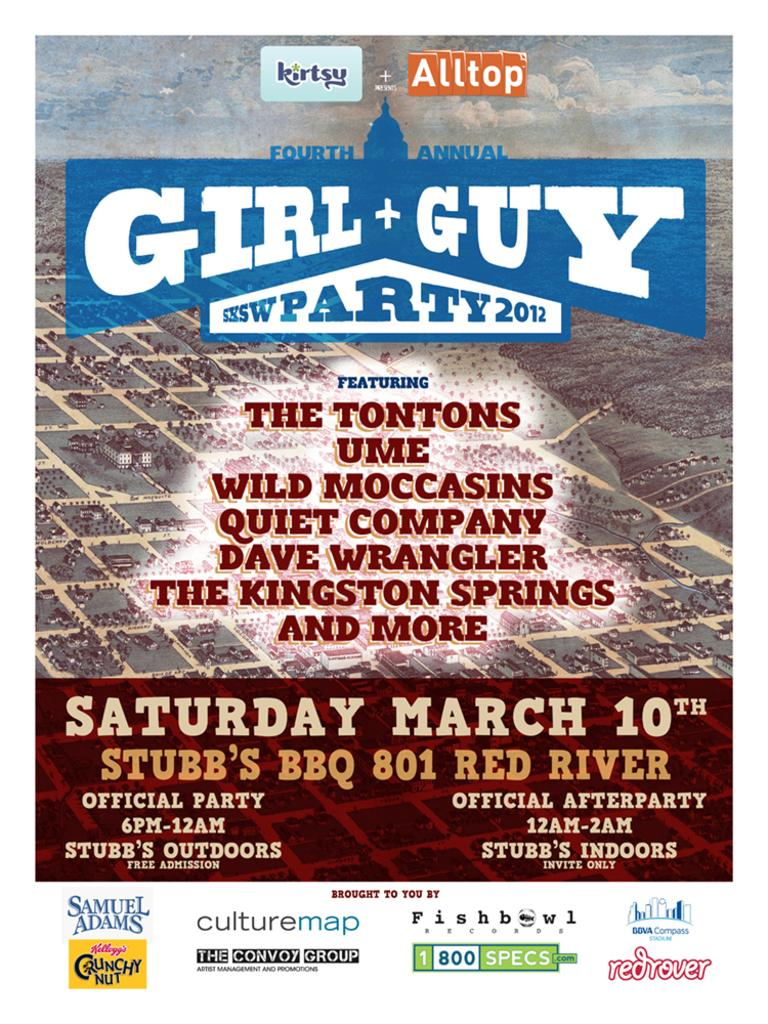<image>
Share a concise interpretation of the image provided. A busy poster for a party in March featuring a number of acts from 2012. 